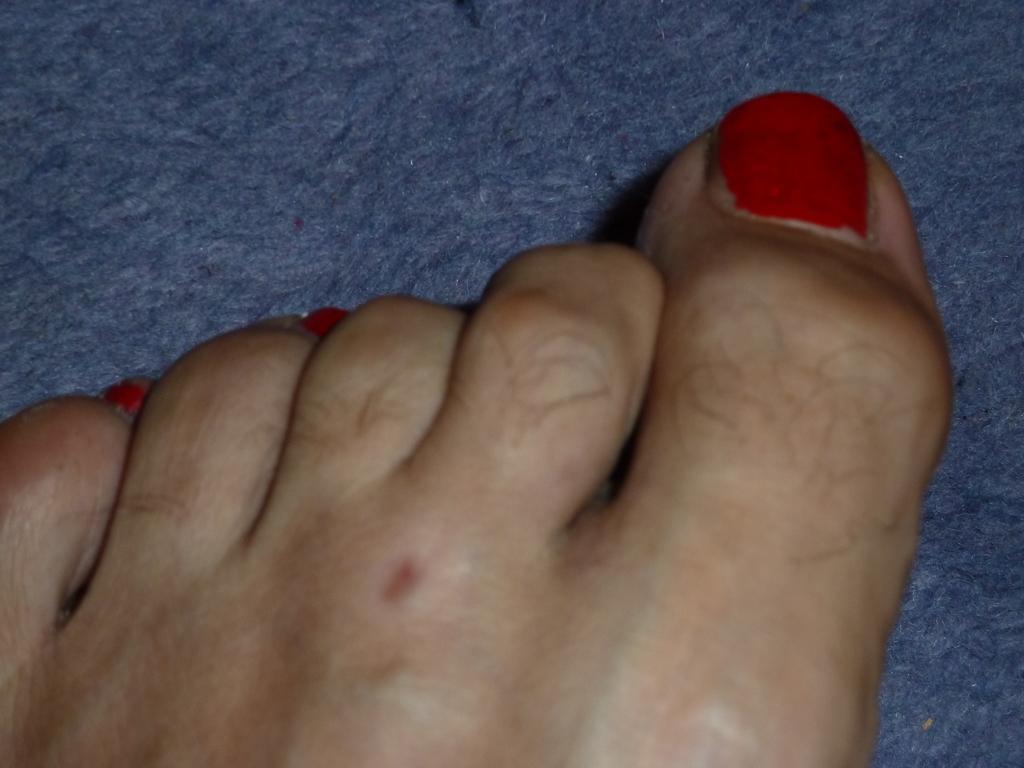Describe this image in one or two sentences. In this image we can see a person's leg. At the bottom there is a mat. 